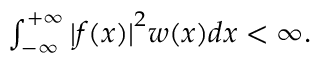Convert formula to latex. <formula><loc_0><loc_0><loc_500><loc_500>\begin{array} { r } { \int _ { - \infty } ^ { + \infty } { | f ( x ) | } ^ { 2 } w ( x ) d x < \infty . } \end{array}</formula> 